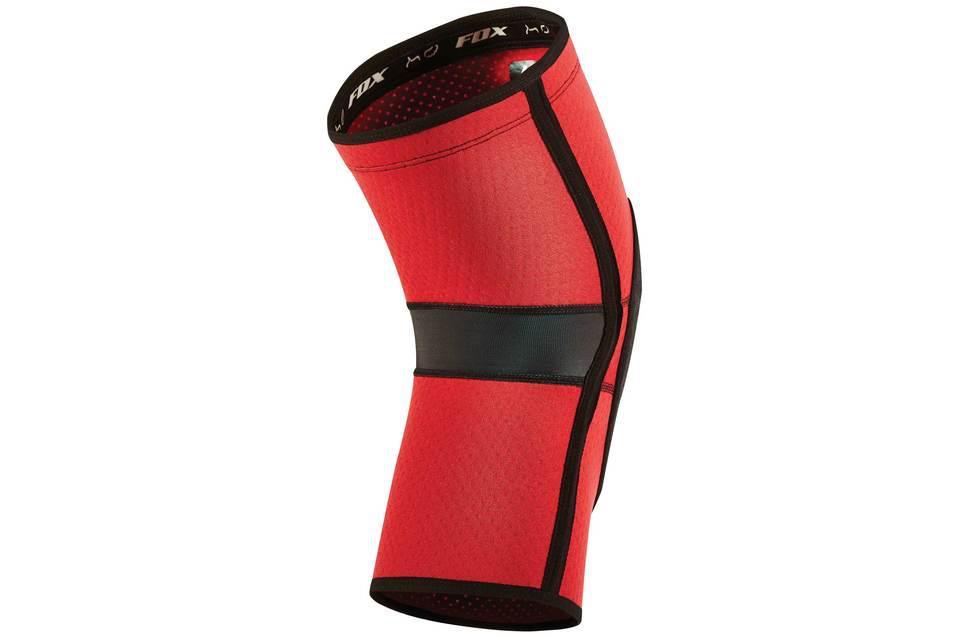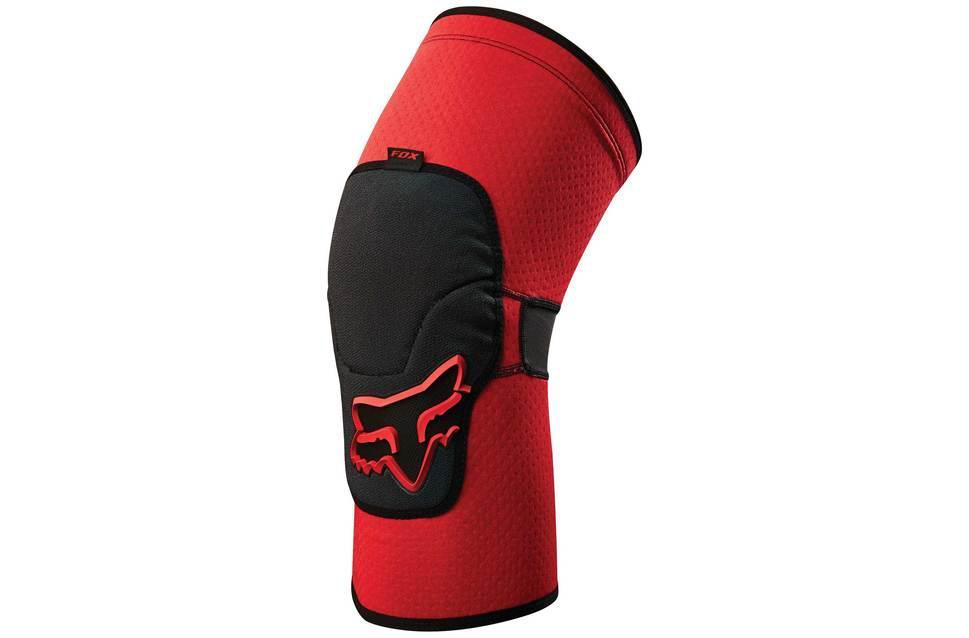The first image is the image on the left, the second image is the image on the right. Considering the images on both sides, is "There are two knee pads that are primarily black in color" valid? Answer yes or no. No. 